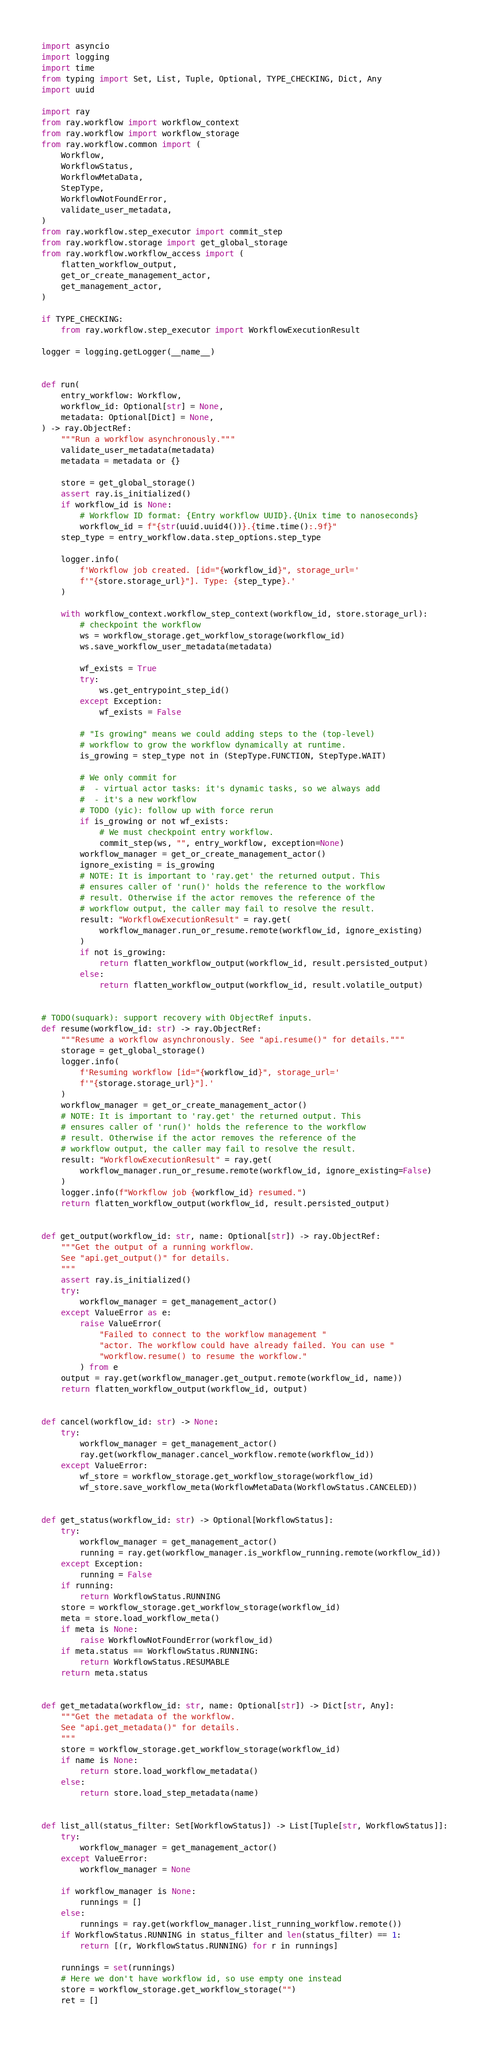Convert code to text. <code><loc_0><loc_0><loc_500><loc_500><_Python_>import asyncio
import logging
import time
from typing import Set, List, Tuple, Optional, TYPE_CHECKING, Dict, Any
import uuid

import ray
from ray.workflow import workflow_context
from ray.workflow import workflow_storage
from ray.workflow.common import (
    Workflow,
    WorkflowStatus,
    WorkflowMetaData,
    StepType,
    WorkflowNotFoundError,
    validate_user_metadata,
)
from ray.workflow.step_executor import commit_step
from ray.workflow.storage import get_global_storage
from ray.workflow.workflow_access import (
    flatten_workflow_output,
    get_or_create_management_actor,
    get_management_actor,
)

if TYPE_CHECKING:
    from ray.workflow.step_executor import WorkflowExecutionResult

logger = logging.getLogger(__name__)


def run(
    entry_workflow: Workflow,
    workflow_id: Optional[str] = None,
    metadata: Optional[Dict] = None,
) -> ray.ObjectRef:
    """Run a workflow asynchronously."""
    validate_user_metadata(metadata)
    metadata = metadata or {}

    store = get_global_storage()
    assert ray.is_initialized()
    if workflow_id is None:
        # Workflow ID format: {Entry workflow UUID}.{Unix time to nanoseconds}
        workflow_id = f"{str(uuid.uuid4())}.{time.time():.9f}"
    step_type = entry_workflow.data.step_options.step_type

    logger.info(
        f'Workflow job created. [id="{workflow_id}", storage_url='
        f'"{store.storage_url}"]. Type: {step_type}.'
    )

    with workflow_context.workflow_step_context(workflow_id, store.storage_url):
        # checkpoint the workflow
        ws = workflow_storage.get_workflow_storage(workflow_id)
        ws.save_workflow_user_metadata(metadata)

        wf_exists = True
        try:
            ws.get_entrypoint_step_id()
        except Exception:
            wf_exists = False

        # "Is growing" means we could adding steps to the (top-level)
        # workflow to grow the workflow dynamically at runtime.
        is_growing = step_type not in (StepType.FUNCTION, StepType.WAIT)

        # We only commit for
        #  - virtual actor tasks: it's dynamic tasks, so we always add
        #  - it's a new workflow
        # TODO (yic): follow up with force rerun
        if is_growing or not wf_exists:
            # We must checkpoint entry workflow.
            commit_step(ws, "", entry_workflow, exception=None)
        workflow_manager = get_or_create_management_actor()
        ignore_existing = is_growing
        # NOTE: It is important to 'ray.get' the returned output. This
        # ensures caller of 'run()' holds the reference to the workflow
        # result. Otherwise if the actor removes the reference of the
        # workflow output, the caller may fail to resolve the result.
        result: "WorkflowExecutionResult" = ray.get(
            workflow_manager.run_or_resume.remote(workflow_id, ignore_existing)
        )
        if not is_growing:
            return flatten_workflow_output(workflow_id, result.persisted_output)
        else:
            return flatten_workflow_output(workflow_id, result.volatile_output)


# TODO(suquark): support recovery with ObjectRef inputs.
def resume(workflow_id: str) -> ray.ObjectRef:
    """Resume a workflow asynchronously. See "api.resume()" for details."""
    storage = get_global_storage()
    logger.info(
        f'Resuming workflow [id="{workflow_id}", storage_url='
        f'"{storage.storage_url}"].'
    )
    workflow_manager = get_or_create_management_actor()
    # NOTE: It is important to 'ray.get' the returned output. This
    # ensures caller of 'run()' holds the reference to the workflow
    # result. Otherwise if the actor removes the reference of the
    # workflow output, the caller may fail to resolve the result.
    result: "WorkflowExecutionResult" = ray.get(
        workflow_manager.run_or_resume.remote(workflow_id, ignore_existing=False)
    )
    logger.info(f"Workflow job {workflow_id} resumed.")
    return flatten_workflow_output(workflow_id, result.persisted_output)


def get_output(workflow_id: str, name: Optional[str]) -> ray.ObjectRef:
    """Get the output of a running workflow.
    See "api.get_output()" for details.
    """
    assert ray.is_initialized()
    try:
        workflow_manager = get_management_actor()
    except ValueError as e:
        raise ValueError(
            "Failed to connect to the workflow management "
            "actor. The workflow could have already failed. You can use "
            "workflow.resume() to resume the workflow."
        ) from e
    output = ray.get(workflow_manager.get_output.remote(workflow_id, name))
    return flatten_workflow_output(workflow_id, output)


def cancel(workflow_id: str) -> None:
    try:
        workflow_manager = get_management_actor()
        ray.get(workflow_manager.cancel_workflow.remote(workflow_id))
    except ValueError:
        wf_store = workflow_storage.get_workflow_storage(workflow_id)
        wf_store.save_workflow_meta(WorkflowMetaData(WorkflowStatus.CANCELED))


def get_status(workflow_id: str) -> Optional[WorkflowStatus]:
    try:
        workflow_manager = get_management_actor()
        running = ray.get(workflow_manager.is_workflow_running.remote(workflow_id))
    except Exception:
        running = False
    if running:
        return WorkflowStatus.RUNNING
    store = workflow_storage.get_workflow_storage(workflow_id)
    meta = store.load_workflow_meta()
    if meta is None:
        raise WorkflowNotFoundError(workflow_id)
    if meta.status == WorkflowStatus.RUNNING:
        return WorkflowStatus.RESUMABLE
    return meta.status


def get_metadata(workflow_id: str, name: Optional[str]) -> Dict[str, Any]:
    """Get the metadata of the workflow.
    See "api.get_metadata()" for details.
    """
    store = workflow_storage.get_workflow_storage(workflow_id)
    if name is None:
        return store.load_workflow_metadata()
    else:
        return store.load_step_metadata(name)


def list_all(status_filter: Set[WorkflowStatus]) -> List[Tuple[str, WorkflowStatus]]:
    try:
        workflow_manager = get_management_actor()
    except ValueError:
        workflow_manager = None

    if workflow_manager is None:
        runnings = []
    else:
        runnings = ray.get(workflow_manager.list_running_workflow.remote())
    if WorkflowStatus.RUNNING in status_filter and len(status_filter) == 1:
        return [(r, WorkflowStatus.RUNNING) for r in runnings]

    runnings = set(runnings)
    # Here we don't have workflow id, so use empty one instead
    store = workflow_storage.get_workflow_storage("")
    ret = []</code> 